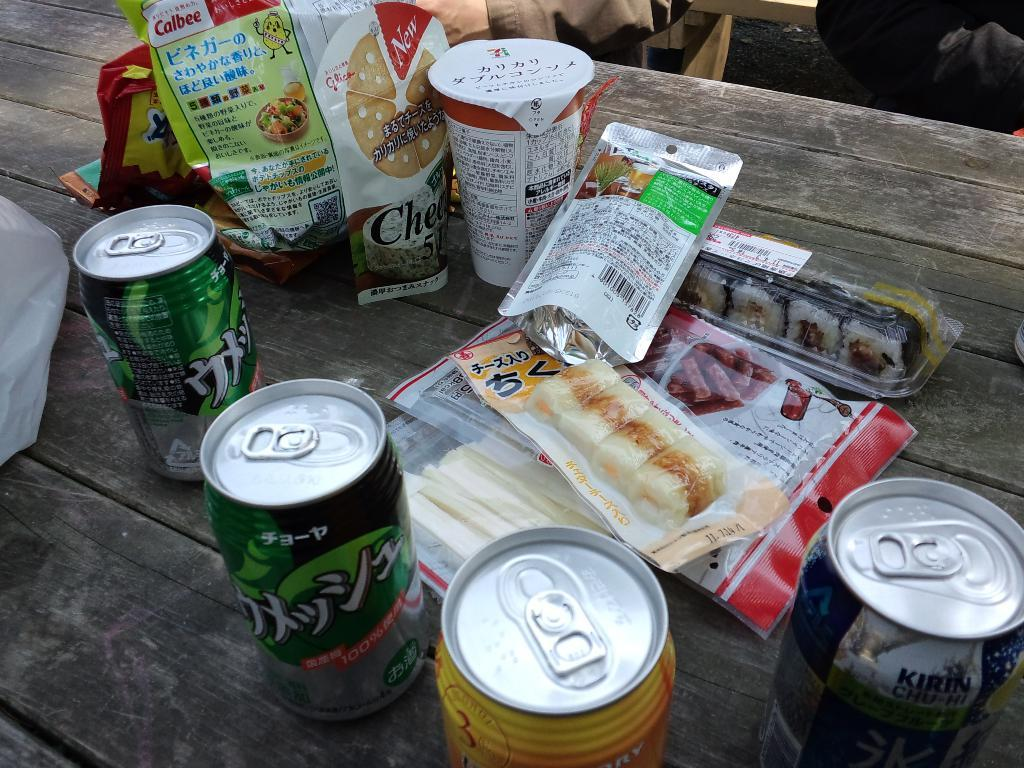Provide a one-sentence caption for the provided image. A can of Kirin Chu-Hi is among the food and beverages on the wood table. 